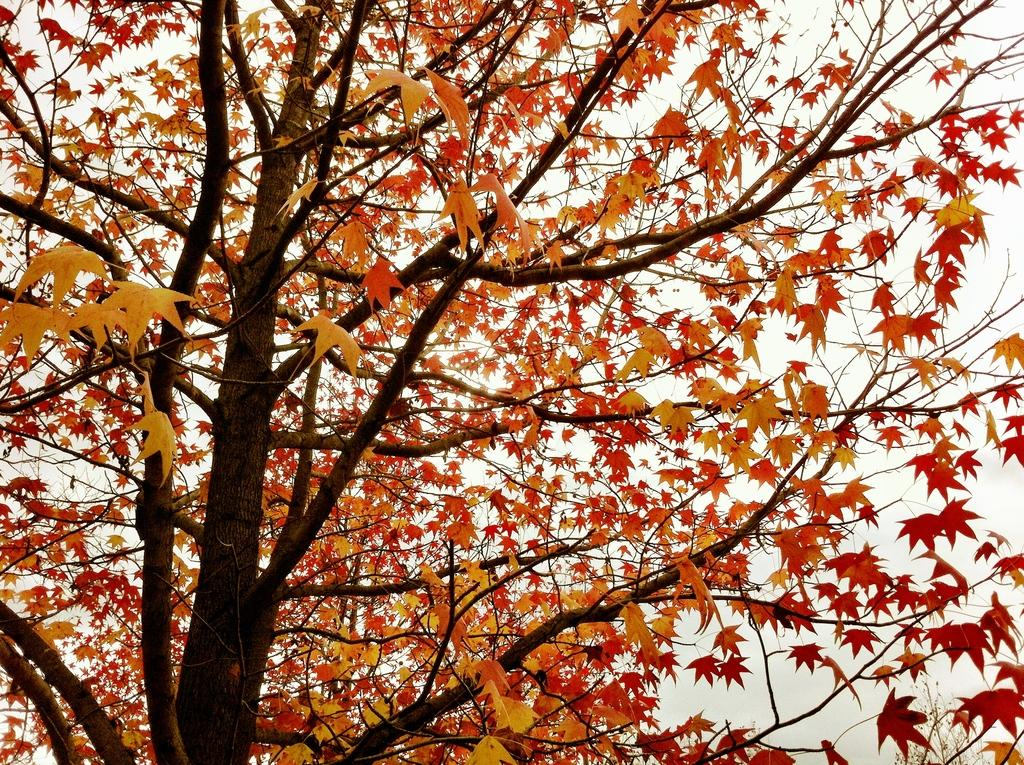What type of tree is in the image? The tree in the image has maple leaves. What can be inferred about the season based on the tree's leaves? The presence of maple leaves suggests that the image was taken during the fall season. What color is the background of the image? The background of the image is white. Can you tell me how many items were ordered from the store in the image? There is no store or order present in the image; it features a tree with maple leaves against a white background. 